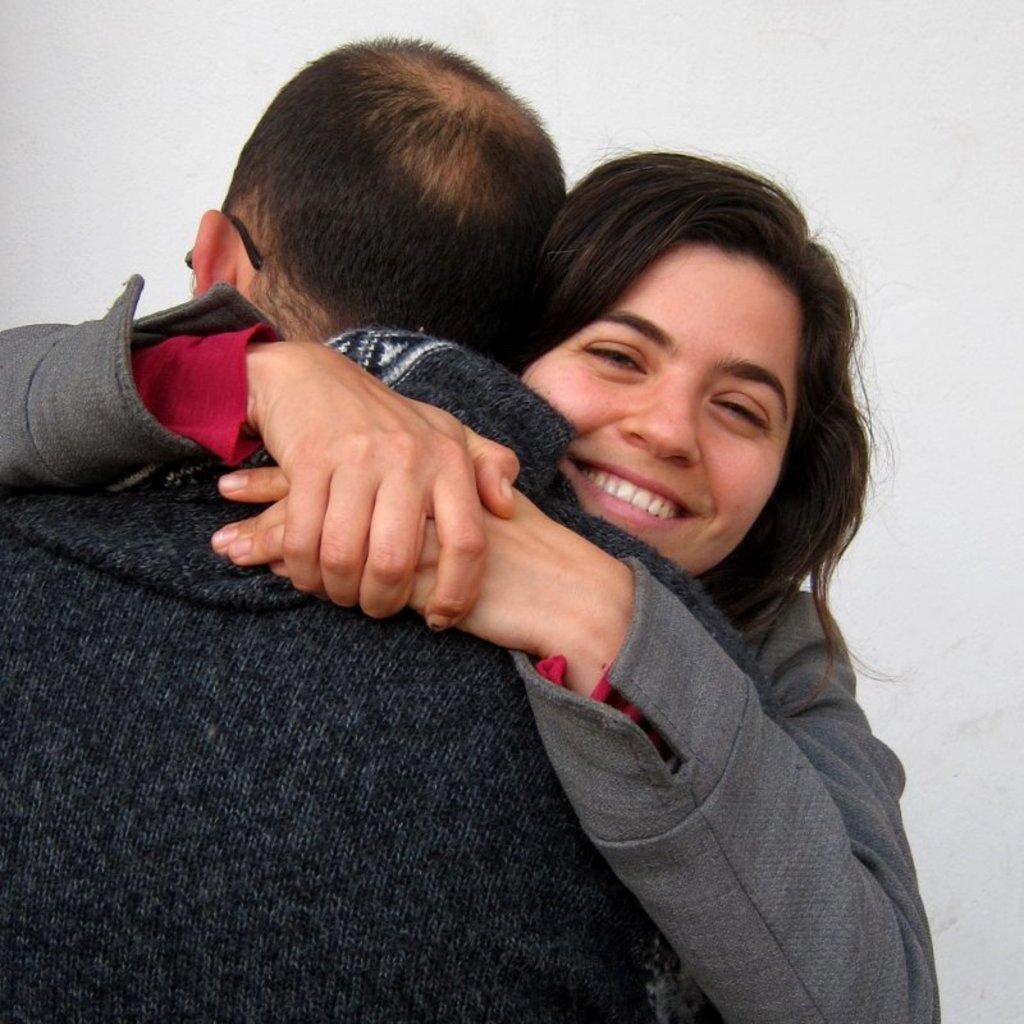Describe this image in one or two sentences. There are two people holding each other and she is smiling. In the background it is white. 